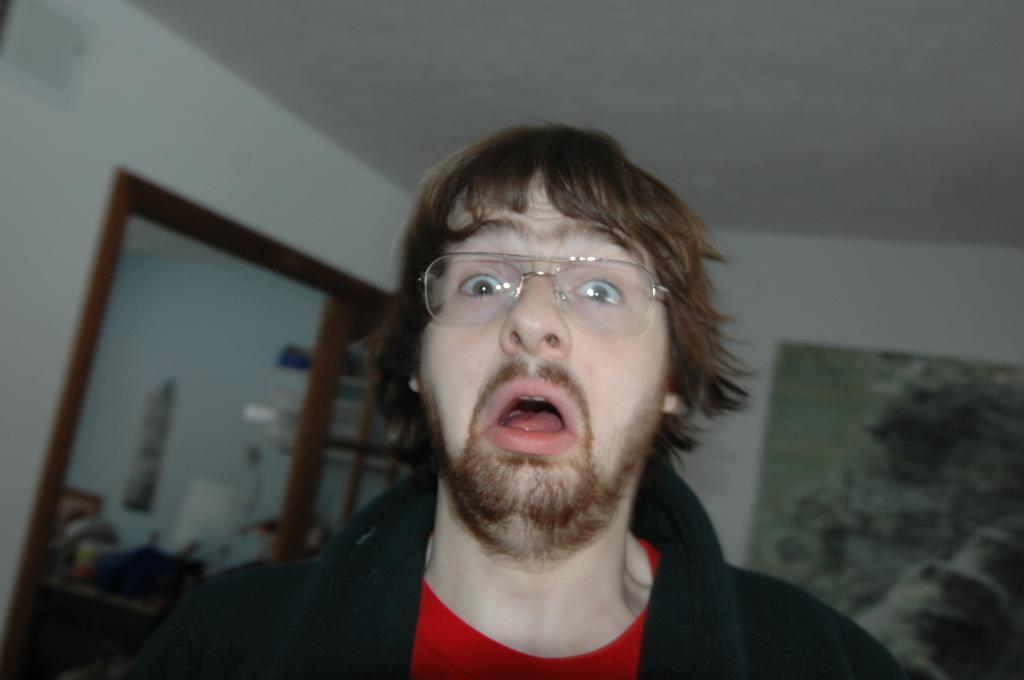Who is present in the image? There is a man in the image. What is the man doing in the image? The man is standing in a room and giving a shocked expression. What can be seen behind the man in the image? There are many things visible behind the man. What type of volleyball technique is the man demonstrating in the image? There is no volleyball present in the image, so it is not possible to determine any volleyball techniques. 